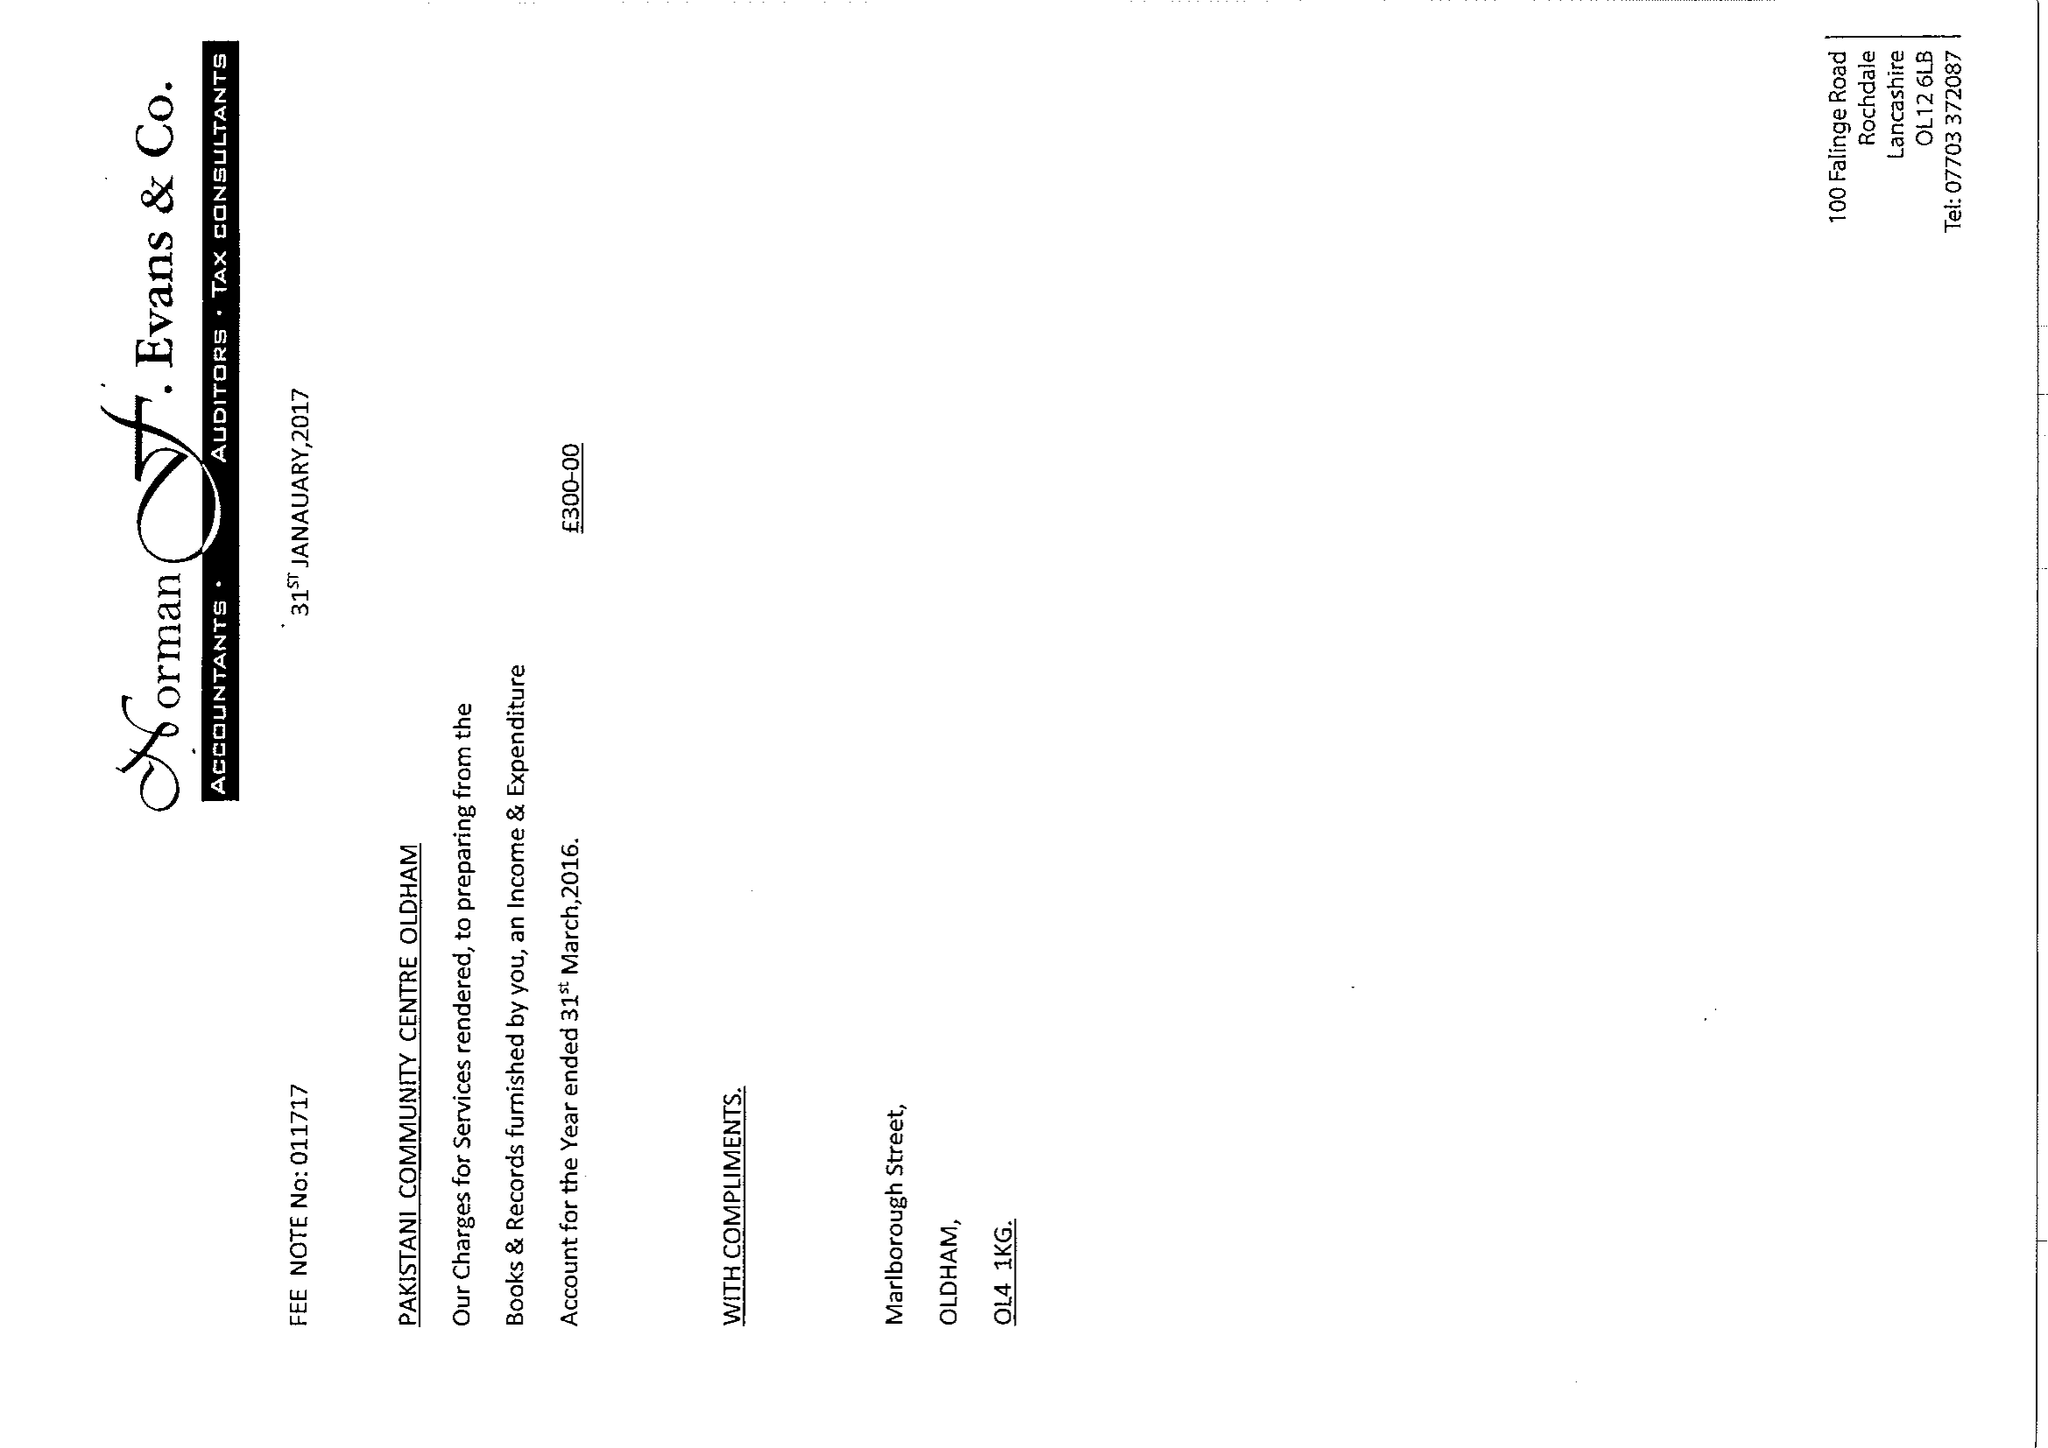What is the value for the address__post_town?
Answer the question using a single word or phrase. OLDHAM 